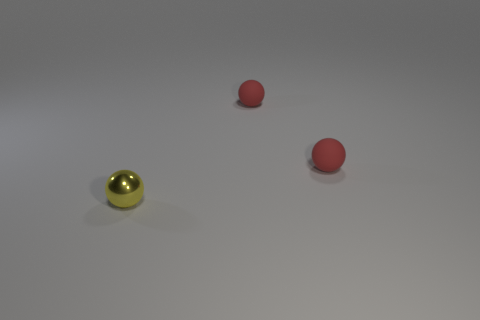Add 2 tiny yellow shiny spheres. How many objects exist? 5 Add 2 yellow metallic things. How many yellow metallic things exist? 3 Subtract 0 brown cubes. How many objects are left? 3 Subtract all large yellow rubber spheres. Subtract all yellow metal objects. How many objects are left? 2 Add 3 tiny metal balls. How many tiny metal balls are left? 4 